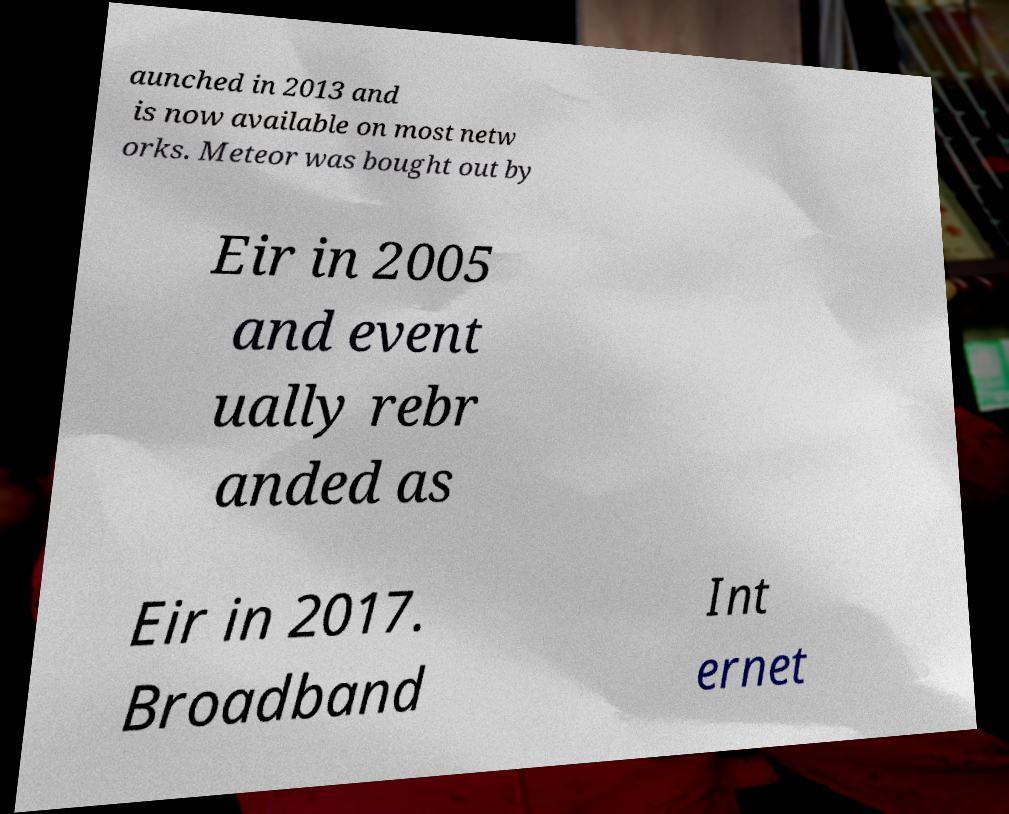Could you assist in decoding the text presented in this image and type it out clearly? aunched in 2013 and is now available on most netw orks. Meteor was bought out by Eir in 2005 and event ually rebr anded as Eir in 2017. Broadband Int ernet 